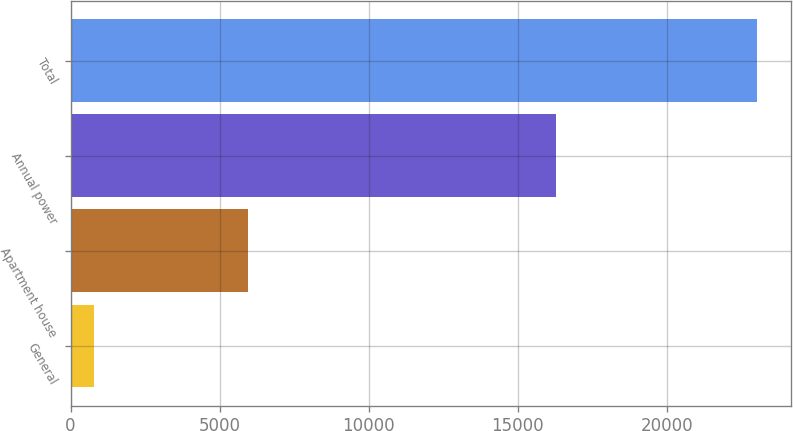Convert chart to OTSL. <chart><loc_0><loc_0><loc_500><loc_500><bar_chart><fcel>General<fcel>Apartment house<fcel>Annual power<fcel>Total<nl><fcel>786<fcel>5962<fcel>16269<fcel>23017<nl></chart> 